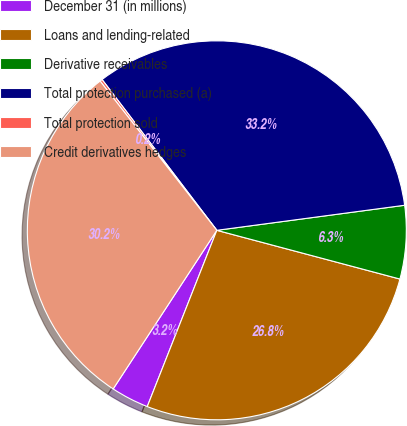<chart> <loc_0><loc_0><loc_500><loc_500><pie_chart><fcel>December 31 (in millions)<fcel>Loans and lending-related<fcel>Derivative receivables<fcel>Total protection purchased (a)<fcel>Total protection sold<fcel>Credit derivatives hedges<nl><fcel>3.23%<fcel>26.84%<fcel>6.25%<fcel>33.24%<fcel>0.21%<fcel>30.22%<nl></chart> 